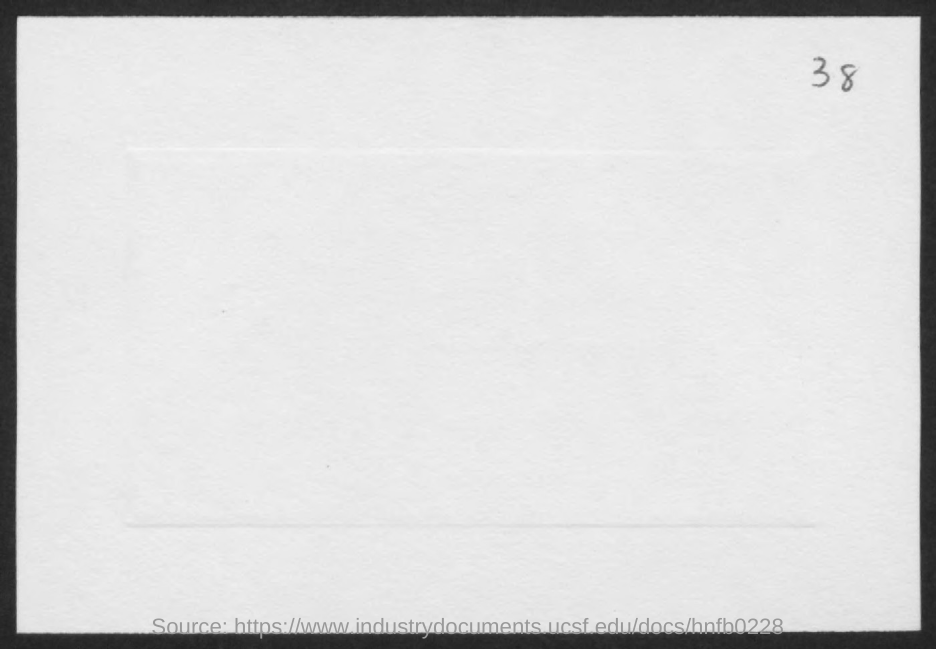What is the Page Number?
Offer a very short reply. 38. 